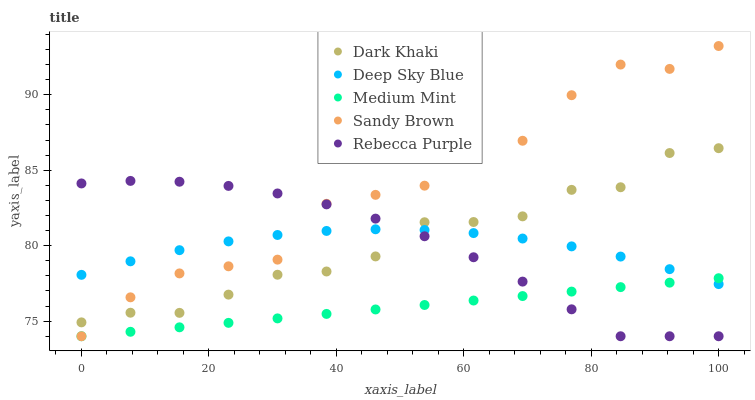Does Medium Mint have the minimum area under the curve?
Answer yes or no. Yes. Does Sandy Brown have the maximum area under the curve?
Answer yes or no. Yes. Does Sandy Brown have the minimum area under the curve?
Answer yes or no. No. Does Medium Mint have the maximum area under the curve?
Answer yes or no. No. Is Medium Mint the smoothest?
Answer yes or no. Yes. Is Sandy Brown the roughest?
Answer yes or no. Yes. Is Sandy Brown the smoothest?
Answer yes or no. No. Is Medium Mint the roughest?
Answer yes or no. No. Does Medium Mint have the lowest value?
Answer yes or no. Yes. Does Deep Sky Blue have the lowest value?
Answer yes or no. No. Does Sandy Brown have the highest value?
Answer yes or no. Yes. Does Medium Mint have the highest value?
Answer yes or no. No. Is Medium Mint less than Dark Khaki?
Answer yes or no. Yes. Is Dark Khaki greater than Medium Mint?
Answer yes or no. Yes. Does Deep Sky Blue intersect Dark Khaki?
Answer yes or no. Yes. Is Deep Sky Blue less than Dark Khaki?
Answer yes or no. No. Is Deep Sky Blue greater than Dark Khaki?
Answer yes or no. No. Does Medium Mint intersect Dark Khaki?
Answer yes or no. No. 